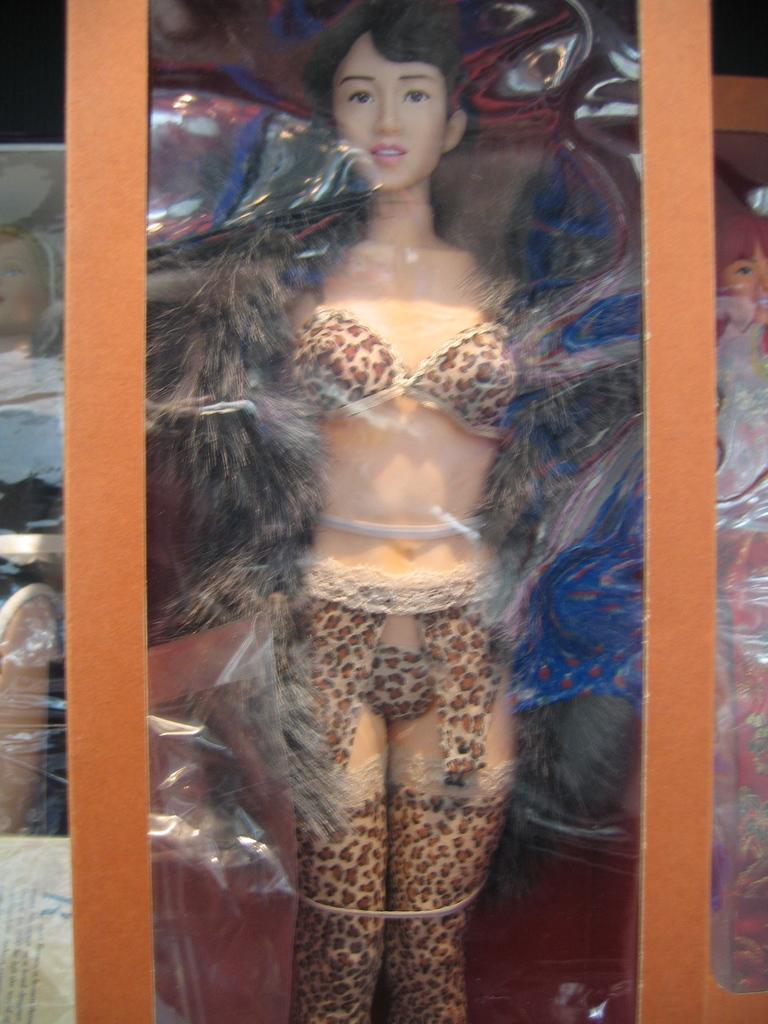What is the main subject of the image? The main subject of the image is depictions of women wearing different clothes. How are the depictions of women arranged in the image? The depictions are packed in a box. Where is the box located in the image? The box is arranged in a rack. What type of brick is used to construct the woman's dress in the image? There is no brick present in the image, and the woman's dress is a depiction, not a physical object. 